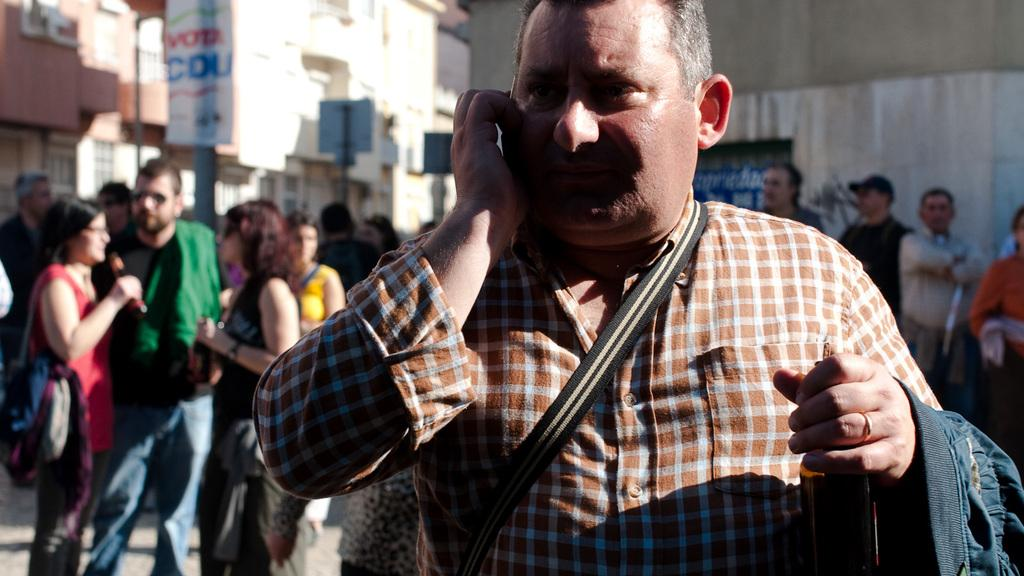Who is the main subject in the image? There is a man in the image. What can be seen in the background of the image? There is a group of people, buildings, and some objects visible in the background of the image. What type of paste is being used by the insect in the image? There is no insect present in the image, so it is not possible to determine what type of paste might be used. 